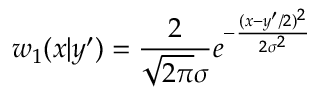<formula> <loc_0><loc_0><loc_500><loc_500>w _ { 1 } ( x | y ^ { \prime } ) = { \frac { 2 } { \sqrt { 2 \pi } \sigma } } e ^ { - { \frac { ( x - y ^ { \prime } / 2 ) ^ { 2 } } { 2 \sigma ^ { 2 } } } }</formula> 